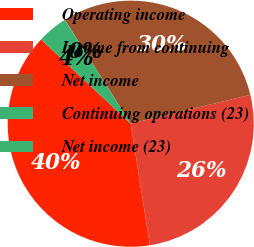Convert chart to OTSL. <chart><loc_0><loc_0><loc_500><loc_500><pie_chart><fcel>Operating income<fcel>Income from continuing<fcel>Net income<fcel>Continuing operations (23)<fcel>Net income (23)<nl><fcel>39.5%<fcel>26.28%<fcel>30.23%<fcel>0.02%<fcel>3.97%<nl></chart> 